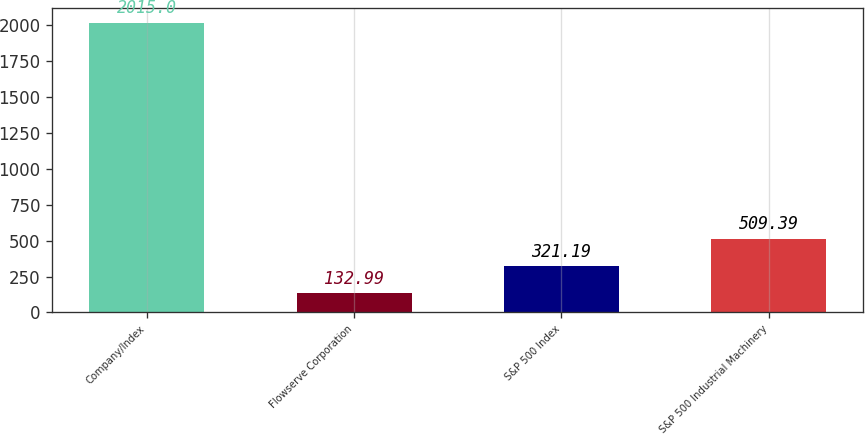Convert chart to OTSL. <chart><loc_0><loc_0><loc_500><loc_500><bar_chart><fcel>Company/Index<fcel>Flowserve Corporation<fcel>S&P 500 Index<fcel>S&P 500 Industrial Machinery<nl><fcel>2015<fcel>132.99<fcel>321.19<fcel>509.39<nl></chart> 